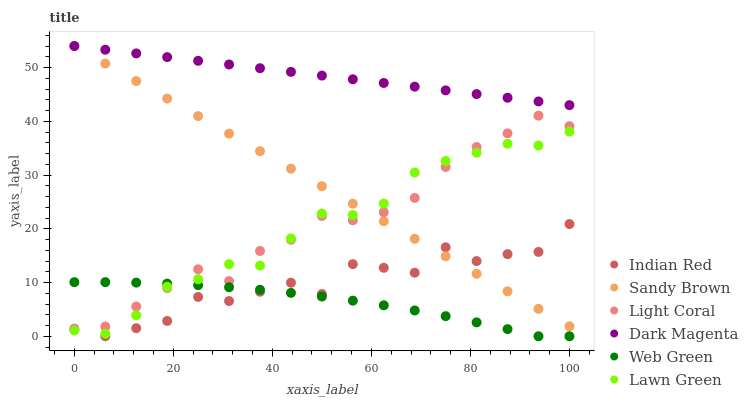Does Web Green have the minimum area under the curve?
Answer yes or no. Yes. Does Dark Magenta have the maximum area under the curve?
Answer yes or no. Yes. Does Dark Magenta have the minimum area under the curve?
Answer yes or no. No. Does Web Green have the maximum area under the curve?
Answer yes or no. No. Is Sandy Brown the smoothest?
Answer yes or no. Yes. Is Indian Red the roughest?
Answer yes or no. Yes. Is Dark Magenta the smoothest?
Answer yes or no. No. Is Dark Magenta the roughest?
Answer yes or no. No. Does Web Green have the lowest value?
Answer yes or no. Yes. Does Dark Magenta have the lowest value?
Answer yes or no. No. Does Sandy Brown have the highest value?
Answer yes or no. Yes. Does Web Green have the highest value?
Answer yes or no. No. Is Light Coral less than Dark Magenta?
Answer yes or no. Yes. Is Dark Magenta greater than Light Coral?
Answer yes or no. Yes. Does Sandy Brown intersect Lawn Green?
Answer yes or no. Yes. Is Sandy Brown less than Lawn Green?
Answer yes or no. No. Is Sandy Brown greater than Lawn Green?
Answer yes or no. No. Does Light Coral intersect Dark Magenta?
Answer yes or no. No. 